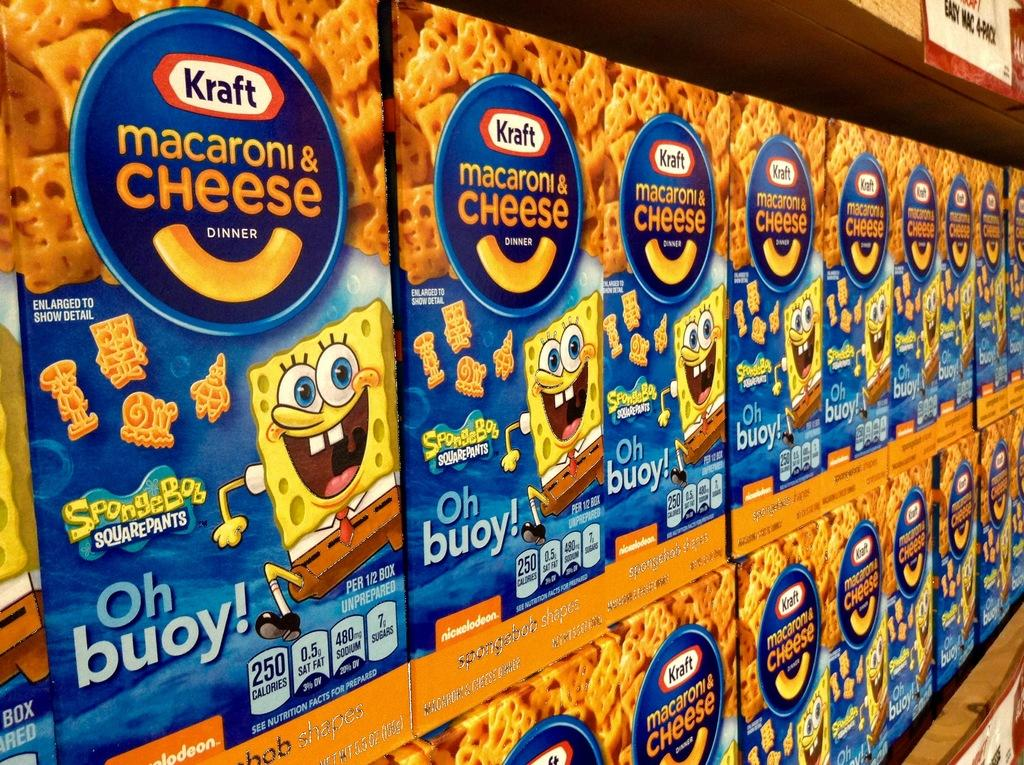What type of objects can be seen in the image with text and images on them? There are boxes with text and images in the image. Can you describe the wooden object in the image? There is a wooden object with a sticker in the image. What type of operation is being performed in the cave shown in the image? There is no cave or operation present in the image; it only features boxes with text and images and a wooden object with a sticker. Is the mailbox located near the wooden object in the image? There is no mailbox present in the image. 